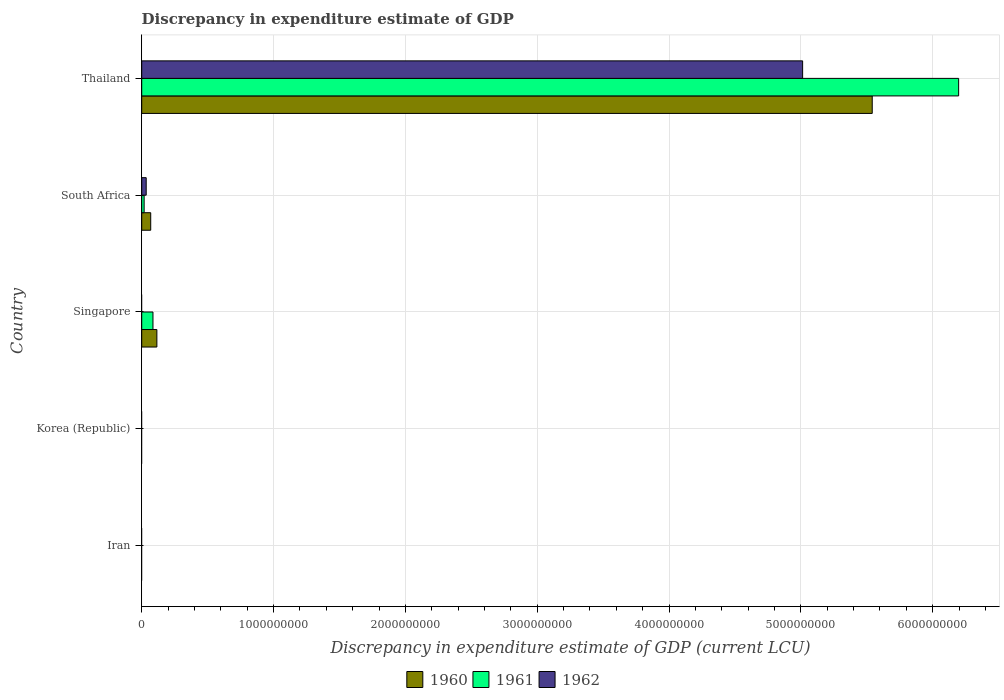How many different coloured bars are there?
Your answer should be very brief. 3. Are the number of bars per tick equal to the number of legend labels?
Provide a short and direct response. No. How many bars are there on the 2nd tick from the top?
Offer a terse response. 3. What is the label of the 2nd group of bars from the top?
Make the answer very short. South Africa. In how many cases, is the number of bars for a given country not equal to the number of legend labels?
Make the answer very short. 3. Across all countries, what is the maximum discrepancy in expenditure estimate of GDP in 1960?
Your answer should be very brief. 5.54e+09. Across all countries, what is the minimum discrepancy in expenditure estimate of GDP in 1961?
Keep it short and to the point. 0. In which country was the discrepancy in expenditure estimate of GDP in 1962 maximum?
Provide a short and direct response. Thailand. What is the total discrepancy in expenditure estimate of GDP in 1960 in the graph?
Your answer should be very brief. 5.72e+09. What is the difference between the discrepancy in expenditure estimate of GDP in 1960 in Thailand and the discrepancy in expenditure estimate of GDP in 1962 in Iran?
Ensure brevity in your answer.  5.54e+09. What is the average discrepancy in expenditure estimate of GDP in 1961 per country?
Your answer should be compact. 1.26e+09. What is the difference between the discrepancy in expenditure estimate of GDP in 1960 and discrepancy in expenditure estimate of GDP in 1961 in Singapore?
Make the answer very short. 2.96e+07. What is the ratio of the discrepancy in expenditure estimate of GDP in 1962 in South Africa to that in Thailand?
Your answer should be compact. 0.01. Is the discrepancy in expenditure estimate of GDP in 1961 in South Africa less than that in Thailand?
Make the answer very short. Yes. Is the difference between the discrepancy in expenditure estimate of GDP in 1960 in South Africa and Thailand greater than the difference between the discrepancy in expenditure estimate of GDP in 1961 in South Africa and Thailand?
Provide a succinct answer. Yes. What is the difference between the highest and the second highest discrepancy in expenditure estimate of GDP in 1961?
Provide a succinct answer. 6.11e+09. What is the difference between the highest and the lowest discrepancy in expenditure estimate of GDP in 1961?
Make the answer very short. 6.20e+09. Is the sum of the discrepancy in expenditure estimate of GDP in 1961 in Singapore and Thailand greater than the maximum discrepancy in expenditure estimate of GDP in 1962 across all countries?
Keep it short and to the point. Yes. Are all the bars in the graph horizontal?
Provide a short and direct response. Yes. How many countries are there in the graph?
Your response must be concise. 5. Are the values on the major ticks of X-axis written in scientific E-notation?
Offer a terse response. No. Does the graph contain any zero values?
Make the answer very short. Yes. Does the graph contain grids?
Keep it short and to the point. Yes. Where does the legend appear in the graph?
Provide a succinct answer. Bottom center. How many legend labels are there?
Provide a short and direct response. 3. How are the legend labels stacked?
Ensure brevity in your answer.  Horizontal. What is the title of the graph?
Offer a terse response. Discrepancy in expenditure estimate of GDP. Does "1963" appear as one of the legend labels in the graph?
Your answer should be compact. No. What is the label or title of the X-axis?
Provide a succinct answer. Discrepancy in expenditure estimate of GDP (current LCU). What is the Discrepancy in expenditure estimate of GDP (current LCU) in 1960 in Iran?
Provide a succinct answer. 0. What is the Discrepancy in expenditure estimate of GDP (current LCU) of 1961 in Iran?
Provide a succinct answer. 0. What is the Discrepancy in expenditure estimate of GDP (current LCU) of 1962 in Iran?
Your response must be concise. 0. What is the Discrepancy in expenditure estimate of GDP (current LCU) in 1961 in Korea (Republic)?
Your answer should be very brief. 0. What is the Discrepancy in expenditure estimate of GDP (current LCU) in 1962 in Korea (Republic)?
Your response must be concise. 0. What is the Discrepancy in expenditure estimate of GDP (current LCU) of 1960 in Singapore?
Your response must be concise. 1.15e+08. What is the Discrepancy in expenditure estimate of GDP (current LCU) in 1961 in Singapore?
Make the answer very short. 8.53e+07. What is the Discrepancy in expenditure estimate of GDP (current LCU) of 1962 in Singapore?
Your answer should be very brief. 0. What is the Discrepancy in expenditure estimate of GDP (current LCU) in 1960 in South Africa?
Make the answer very short. 6.83e+07. What is the Discrepancy in expenditure estimate of GDP (current LCU) of 1961 in South Africa?
Your answer should be compact. 1.84e+07. What is the Discrepancy in expenditure estimate of GDP (current LCU) of 1962 in South Africa?
Your answer should be very brief. 3.40e+07. What is the Discrepancy in expenditure estimate of GDP (current LCU) of 1960 in Thailand?
Give a very brief answer. 5.54e+09. What is the Discrepancy in expenditure estimate of GDP (current LCU) in 1961 in Thailand?
Offer a terse response. 6.20e+09. What is the Discrepancy in expenditure estimate of GDP (current LCU) in 1962 in Thailand?
Offer a terse response. 5.01e+09. Across all countries, what is the maximum Discrepancy in expenditure estimate of GDP (current LCU) of 1960?
Your response must be concise. 5.54e+09. Across all countries, what is the maximum Discrepancy in expenditure estimate of GDP (current LCU) of 1961?
Offer a very short reply. 6.20e+09. Across all countries, what is the maximum Discrepancy in expenditure estimate of GDP (current LCU) in 1962?
Keep it short and to the point. 5.01e+09. Across all countries, what is the minimum Discrepancy in expenditure estimate of GDP (current LCU) of 1961?
Provide a succinct answer. 0. What is the total Discrepancy in expenditure estimate of GDP (current LCU) in 1960 in the graph?
Ensure brevity in your answer.  5.72e+09. What is the total Discrepancy in expenditure estimate of GDP (current LCU) in 1961 in the graph?
Keep it short and to the point. 6.30e+09. What is the total Discrepancy in expenditure estimate of GDP (current LCU) in 1962 in the graph?
Ensure brevity in your answer.  5.05e+09. What is the difference between the Discrepancy in expenditure estimate of GDP (current LCU) in 1960 in Singapore and that in South Africa?
Offer a terse response. 4.66e+07. What is the difference between the Discrepancy in expenditure estimate of GDP (current LCU) of 1961 in Singapore and that in South Africa?
Give a very brief answer. 6.69e+07. What is the difference between the Discrepancy in expenditure estimate of GDP (current LCU) in 1960 in Singapore and that in Thailand?
Keep it short and to the point. -5.43e+09. What is the difference between the Discrepancy in expenditure estimate of GDP (current LCU) of 1961 in Singapore and that in Thailand?
Keep it short and to the point. -6.11e+09. What is the difference between the Discrepancy in expenditure estimate of GDP (current LCU) in 1960 in South Africa and that in Thailand?
Give a very brief answer. -5.47e+09. What is the difference between the Discrepancy in expenditure estimate of GDP (current LCU) in 1961 in South Africa and that in Thailand?
Keep it short and to the point. -6.18e+09. What is the difference between the Discrepancy in expenditure estimate of GDP (current LCU) in 1962 in South Africa and that in Thailand?
Offer a very short reply. -4.98e+09. What is the difference between the Discrepancy in expenditure estimate of GDP (current LCU) of 1960 in Singapore and the Discrepancy in expenditure estimate of GDP (current LCU) of 1961 in South Africa?
Offer a very short reply. 9.65e+07. What is the difference between the Discrepancy in expenditure estimate of GDP (current LCU) of 1960 in Singapore and the Discrepancy in expenditure estimate of GDP (current LCU) of 1962 in South Africa?
Provide a short and direct response. 8.09e+07. What is the difference between the Discrepancy in expenditure estimate of GDP (current LCU) of 1961 in Singapore and the Discrepancy in expenditure estimate of GDP (current LCU) of 1962 in South Africa?
Your response must be concise. 5.13e+07. What is the difference between the Discrepancy in expenditure estimate of GDP (current LCU) in 1960 in Singapore and the Discrepancy in expenditure estimate of GDP (current LCU) in 1961 in Thailand?
Provide a short and direct response. -6.08e+09. What is the difference between the Discrepancy in expenditure estimate of GDP (current LCU) in 1960 in Singapore and the Discrepancy in expenditure estimate of GDP (current LCU) in 1962 in Thailand?
Give a very brief answer. -4.90e+09. What is the difference between the Discrepancy in expenditure estimate of GDP (current LCU) in 1961 in Singapore and the Discrepancy in expenditure estimate of GDP (current LCU) in 1962 in Thailand?
Provide a short and direct response. -4.93e+09. What is the difference between the Discrepancy in expenditure estimate of GDP (current LCU) in 1960 in South Africa and the Discrepancy in expenditure estimate of GDP (current LCU) in 1961 in Thailand?
Your answer should be compact. -6.13e+09. What is the difference between the Discrepancy in expenditure estimate of GDP (current LCU) in 1960 in South Africa and the Discrepancy in expenditure estimate of GDP (current LCU) in 1962 in Thailand?
Your response must be concise. -4.95e+09. What is the difference between the Discrepancy in expenditure estimate of GDP (current LCU) of 1961 in South Africa and the Discrepancy in expenditure estimate of GDP (current LCU) of 1962 in Thailand?
Make the answer very short. -5.00e+09. What is the average Discrepancy in expenditure estimate of GDP (current LCU) in 1960 per country?
Ensure brevity in your answer.  1.14e+09. What is the average Discrepancy in expenditure estimate of GDP (current LCU) of 1961 per country?
Give a very brief answer. 1.26e+09. What is the average Discrepancy in expenditure estimate of GDP (current LCU) of 1962 per country?
Ensure brevity in your answer.  1.01e+09. What is the difference between the Discrepancy in expenditure estimate of GDP (current LCU) in 1960 and Discrepancy in expenditure estimate of GDP (current LCU) in 1961 in Singapore?
Offer a terse response. 2.96e+07. What is the difference between the Discrepancy in expenditure estimate of GDP (current LCU) in 1960 and Discrepancy in expenditure estimate of GDP (current LCU) in 1961 in South Africa?
Provide a succinct answer. 4.99e+07. What is the difference between the Discrepancy in expenditure estimate of GDP (current LCU) of 1960 and Discrepancy in expenditure estimate of GDP (current LCU) of 1962 in South Africa?
Offer a very short reply. 3.43e+07. What is the difference between the Discrepancy in expenditure estimate of GDP (current LCU) of 1961 and Discrepancy in expenditure estimate of GDP (current LCU) of 1962 in South Africa?
Offer a very short reply. -1.56e+07. What is the difference between the Discrepancy in expenditure estimate of GDP (current LCU) in 1960 and Discrepancy in expenditure estimate of GDP (current LCU) in 1961 in Thailand?
Your answer should be compact. -6.56e+08. What is the difference between the Discrepancy in expenditure estimate of GDP (current LCU) in 1960 and Discrepancy in expenditure estimate of GDP (current LCU) in 1962 in Thailand?
Your answer should be compact. 5.28e+08. What is the difference between the Discrepancy in expenditure estimate of GDP (current LCU) in 1961 and Discrepancy in expenditure estimate of GDP (current LCU) in 1962 in Thailand?
Your answer should be compact. 1.18e+09. What is the ratio of the Discrepancy in expenditure estimate of GDP (current LCU) in 1960 in Singapore to that in South Africa?
Your response must be concise. 1.68. What is the ratio of the Discrepancy in expenditure estimate of GDP (current LCU) of 1961 in Singapore to that in South Africa?
Offer a terse response. 4.64. What is the ratio of the Discrepancy in expenditure estimate of GDP (current LCU) in 1960 in Singapore to that in Thailand?
Provide a succinct answer. 0.02. What is the ratio of the Discrepancy in expenditure estimate of GDP (current LCU) in 1961 in Singapore to that in Thailand?
Give a very brief answer. 0.01. What is the ratio of the Discrepancy in expenditure estimate of GDP (current LCU) of 1960 in South Africa to that in Thailand?
Offer a terse response. 0.01. What is the ratio of the Discrepancy in expenditure estimate of GDP (current LCU) of 1961 in South Africa to that in Thailand?
Give a very brief answer. 0. What is the ratio of the Discrepancy in expenditure estimate of GDP (current LCU) of 1962 in South Africa to that in Thailand?
Ensure brevity in your answer.  0.01. What is the difference between the highest and the second highest Discrepancy in expenditure estimate of GDP (current LCU) of 1960?
Offer a very short reply. 5.43e+09. What is the difference between the highest and the second highest Discrepancy in expenditure estimate of GDP (current LCU) of 1961?
Offer a terse response. 6.11e+09. What is the difference between the highest and the lowest Discrepancy in expenditure estimate of GDP (current LCU) in 1960?
Provide a short and direct response. 5.54e+09. What is the difference between the highest and the lowest Discrepancy in expenditure estimate of GDP (current LCU) of 1961?
Offer a terse response. 6.20e+09. What is the difference between the highest and the lowest Discrepancy in expenditure estimate of GDP (current LCU) of 1962?
Your response must be concise. 5.01e+09. 